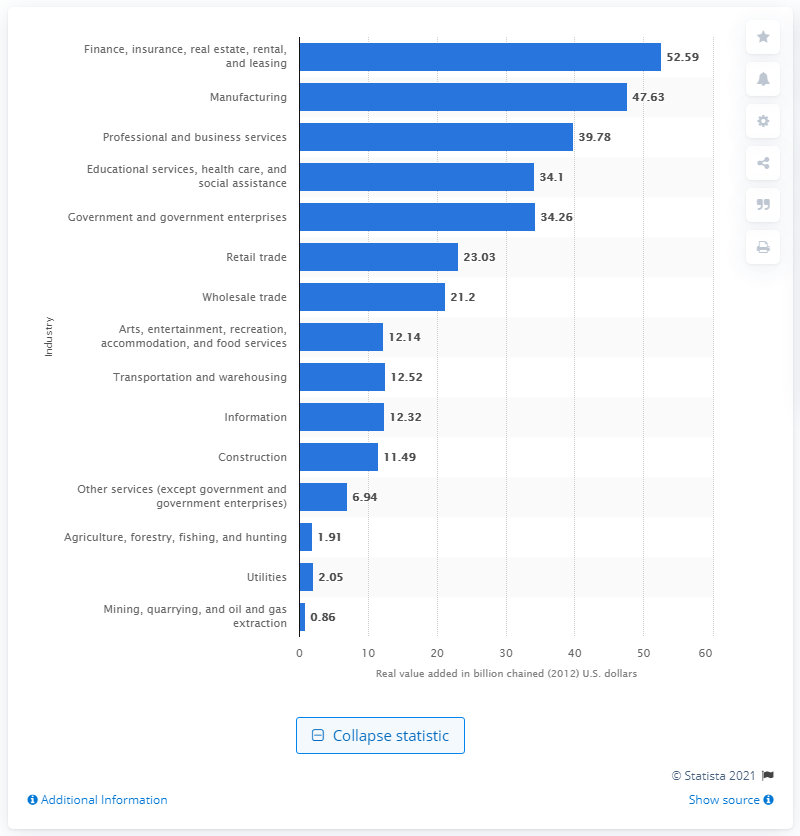Outline some significant characteristics in this image. In 2012, the manufacturing industry contributed $47.63 billion to the total gross domestic product (GDP) of the state of Tennessee. 